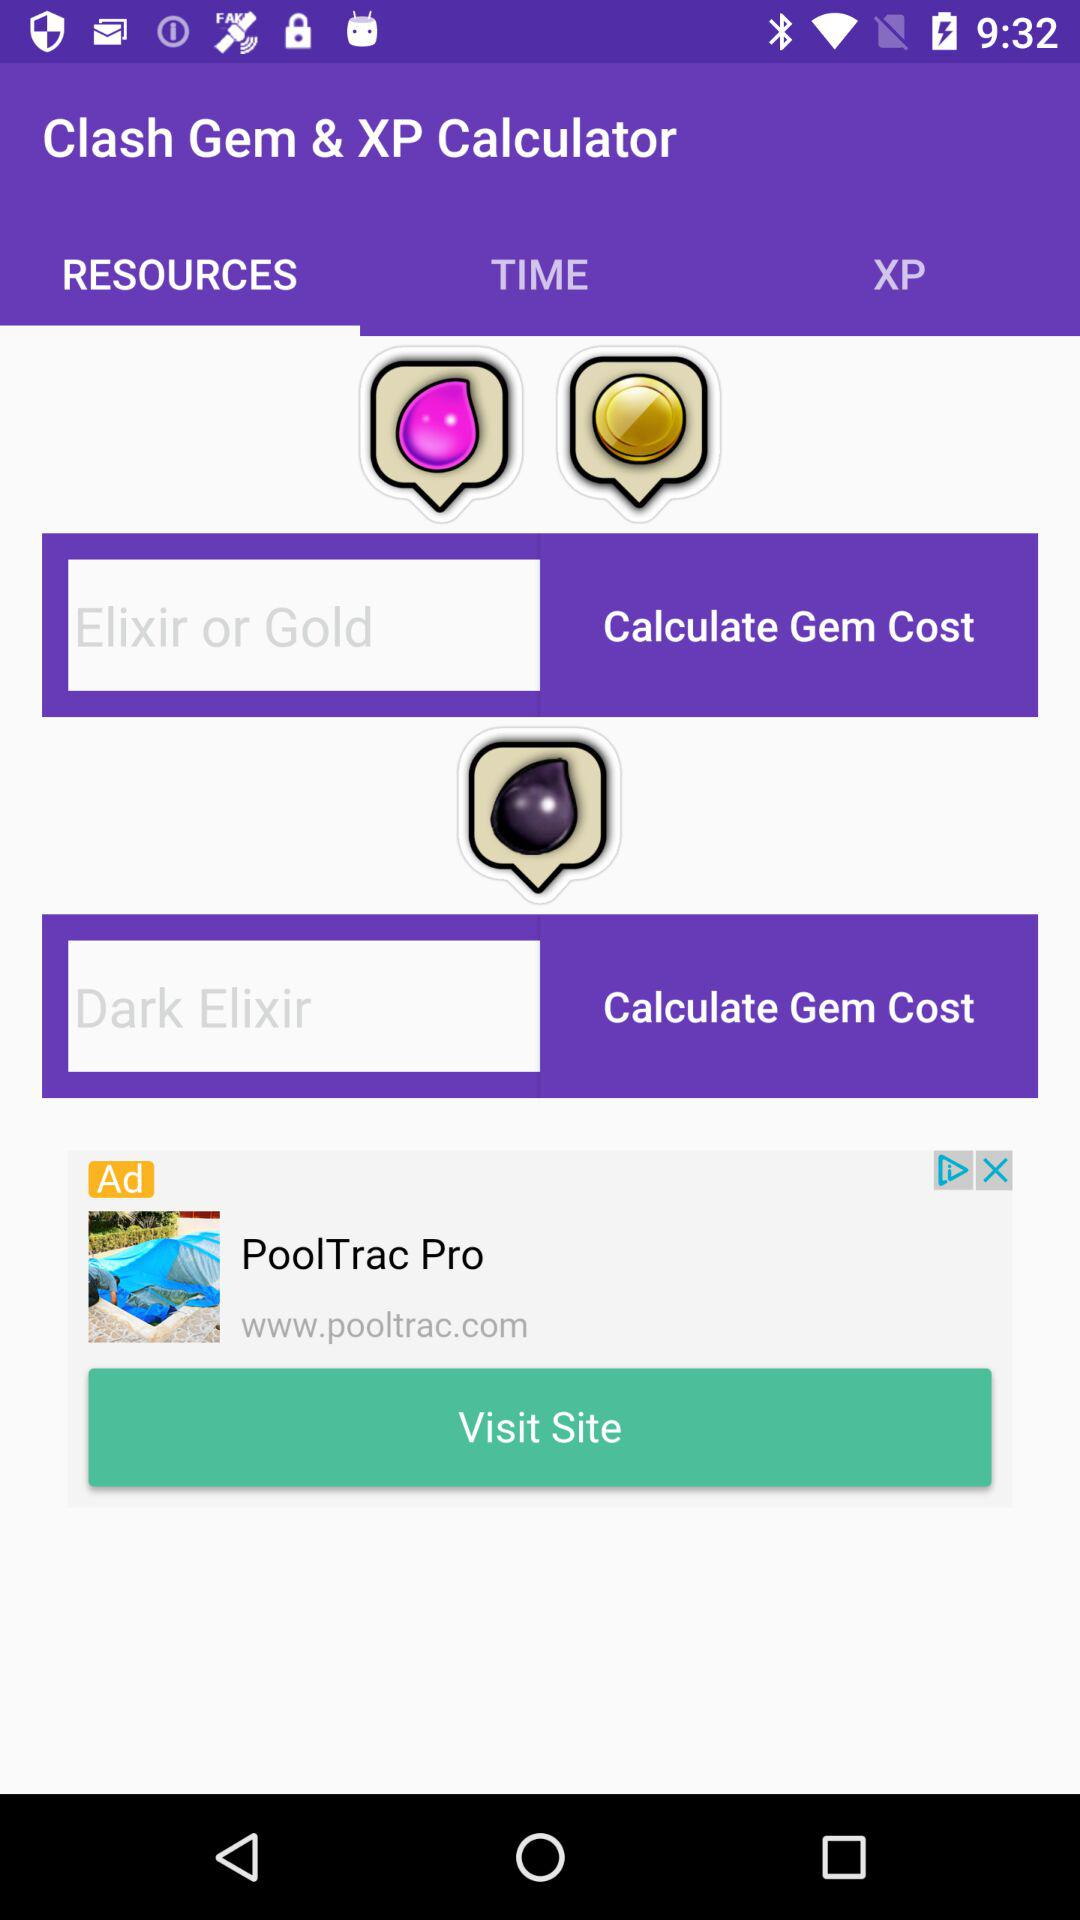Which tab is selected? The selected tab is "RESOURCES". 